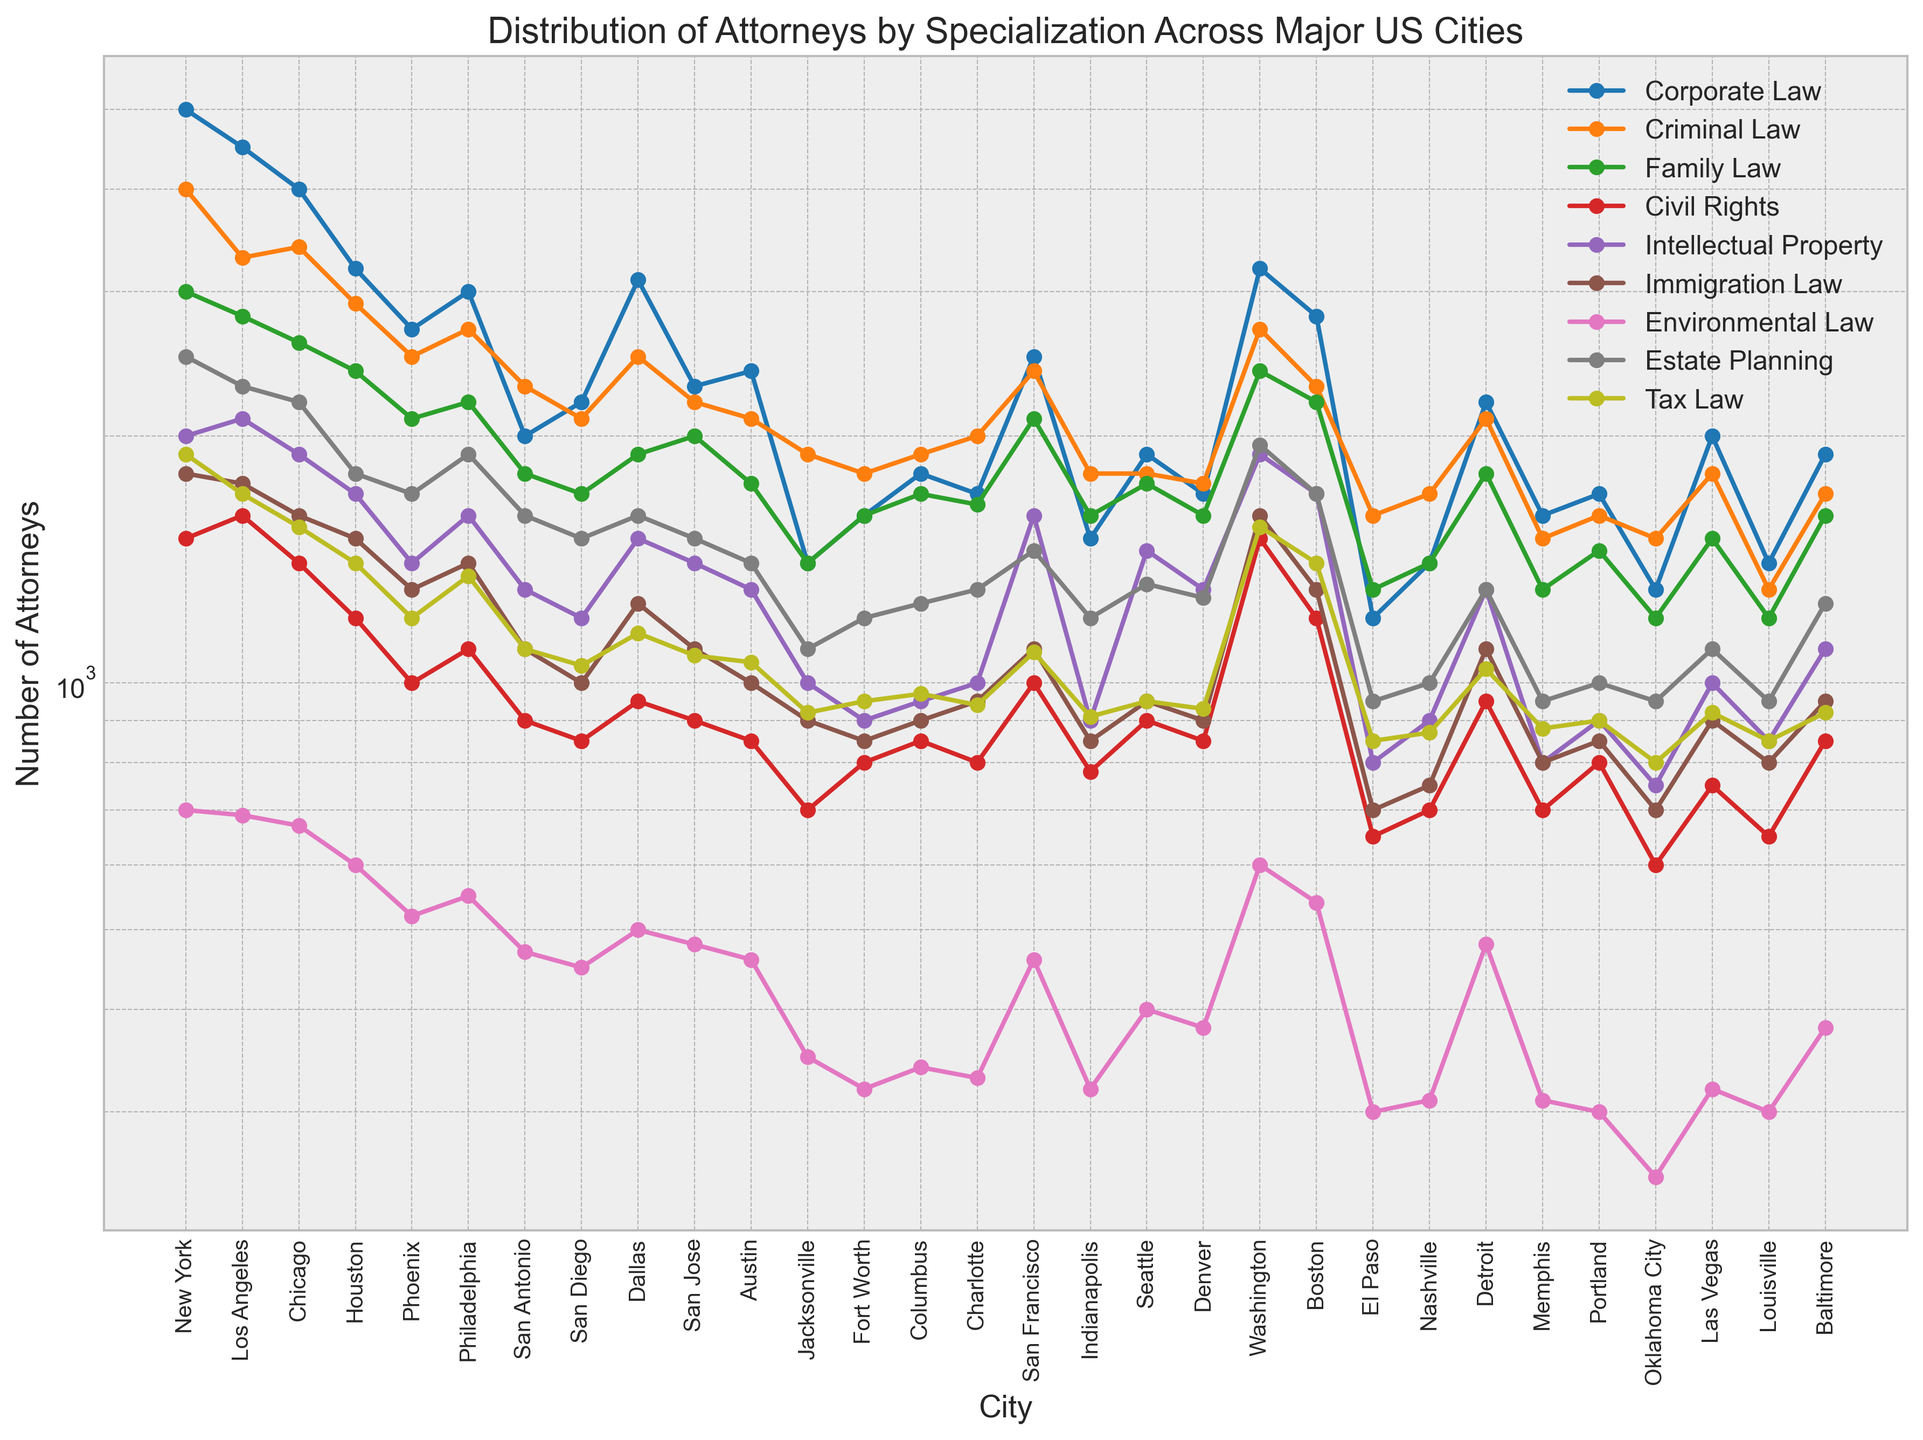What's the city with the highest number of attorneys in Corporate Law? Look at the line that represents Corporate Law and find the city with the highest value on that line.
Answer: New York Which specialization has the highest number of attorneys across all cities combined? Visually inspect each specialization line and summing the values for each city can be a way, but since summing is not straightforward visually, look for the trend across cities and identify the specialization which appears to consistently have high values.
Answer: Corporate Law How does the number of Criminal Law attorneys in Los Angeles compare to those in New York? Check the values on the y-axis for Los Angeles and New York under the Criminal Law line and compare them.
Answer: Los Angeles has fewer Criminal Law attorneys than New York Which city has the least number of attorneys in Environmental Law? Look at the line that represents Environmental Law and find the city with the lowest value on that line.
Answer: Oklahoma City What is the average number of attorneys in Family Law across the cities? To solve this, add the values of Family Law attorneys for each city and divide by the number of cities. Visually estimate or calculate approximately using the plotted points.
Answer: Approximately 1850 (requires precise calculation for exact number) In which city is the ratio of Criminal Law to Family Law attorneys the highest? Identify the Criminal Law and Family Law values for each city and calculate the ratio, then compare these ratios.
Answer: Chicago Do more cities have a higher number of attorneys in Tax Law or in Civil Rights? Compare the values for each city under Tax Law and Civil Rights lines to count which has a higher number in more cities.
Answer: Tax Law Which specialization shows the greatest variation in the number of attorneys across the cities? Observe which line has the most fluctuations and difference in values from city to city.
Answer: Corporate Law Compare the number of attorneys in Intellectual Property versus Immigration Law for San Francisco. Check the values on the y-axis for Intellectual Property and Immigration Law at the point representing San Francisco and compare.
Answer: Intellectual Property has more attorneys Between Dallas and Austin, which city has a higher number of Environmental Law attorneys? Look at the values on the y-axis for Environmental Law at the points representing Dallas and Austin and compare.
Answer: Dallas 